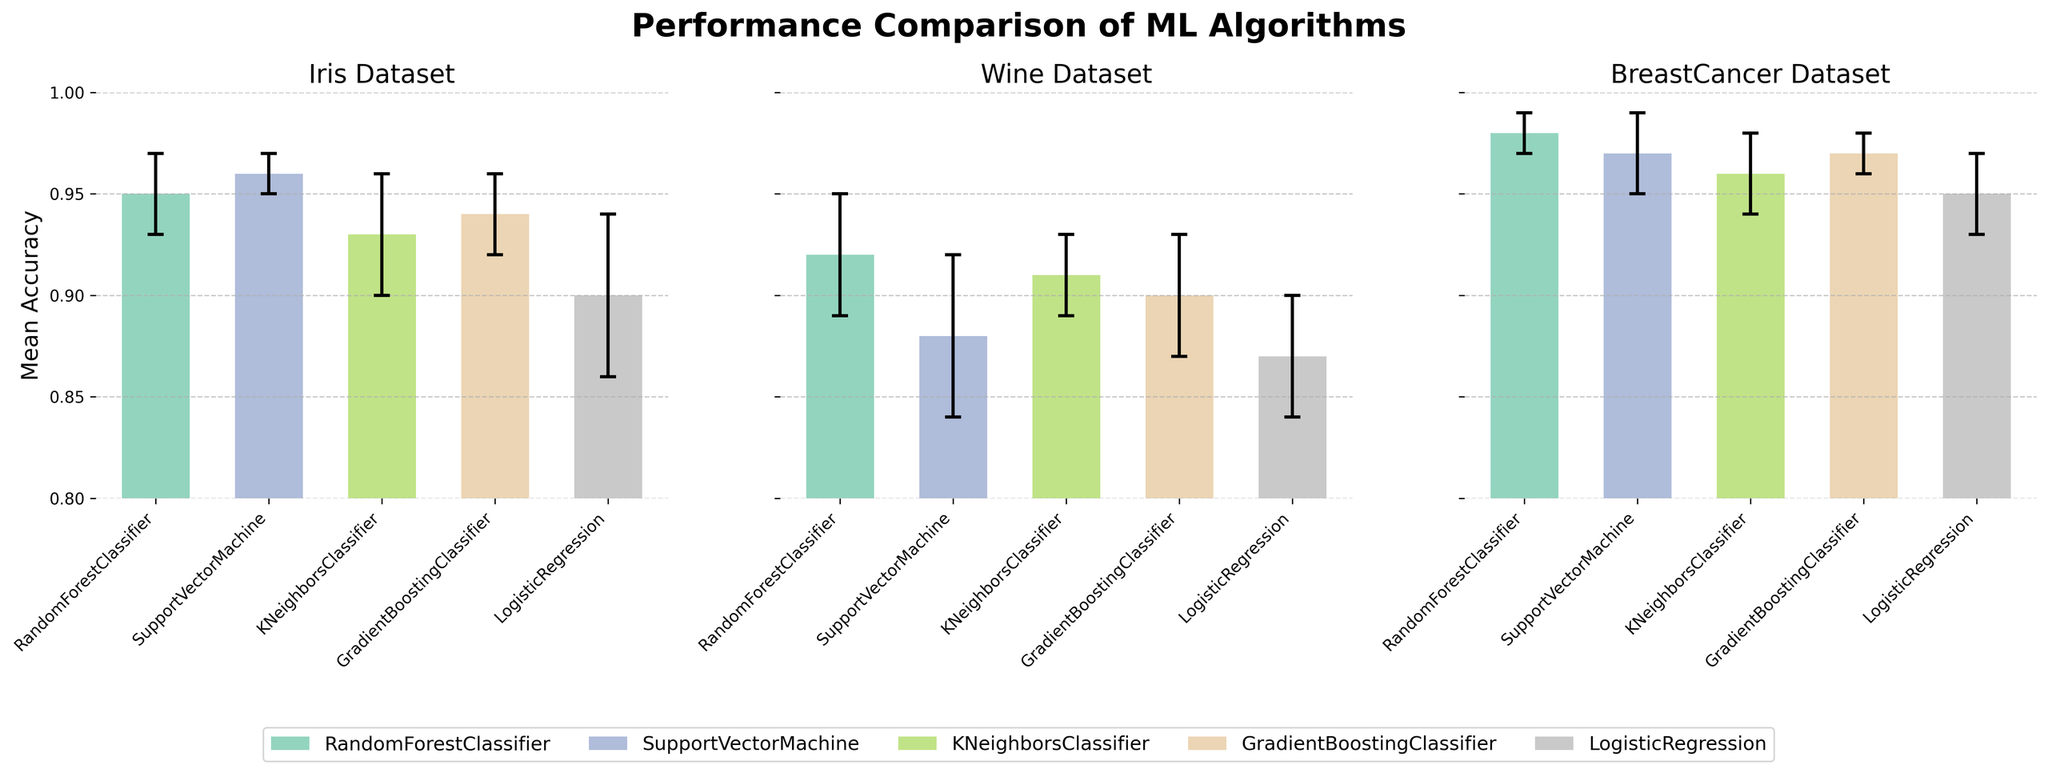Which algorithm has the highest mean accuracy on the Iris dataset? From the Iris dataset subplot, the SupportVectorMachine bar has the highest top compared to other algorithms in terms of mean accuracy.
Answer: SupportVectorMachine Which algorithm has the lowest mean accuracy on the Wine dataset? From the Wine dataset subplot, the LogisticRegression bar is the lowest in terms of mean accuracy.
Answer: LogisticRegression What is the approximate mean accuracy of the RandomForestClassifier on the BreastCancer dataset? In the BreastCancer dataset subplot, the bar for RandomForestClassifier is just below 1.0 on the Mean Accuracy axis.
Answer: 0.98 Compare the mean accuracies of SupportVectorMachine and KNeighborsClassifier on the Wine dataset. Which one is higher? In the Wine dataset subplot, the bar for SupportVectorMachine has a lower mean accuracy than the KNeighborsClassifier.
Answer: KNeighborsClassifier For the Iris dataset, which algorithm has the largest standard deviation in mean accuracy? In the Iris dataset subplot, the LogisticRegression has the longest error bar, indicating the largest standard deviation.
Answer: LogisticRegression Which dataset shows the highest overall mean accuracy across all algorithms? To find the highest overall mean accuracy, compare the tallest bars across subplots. The BreastCancer dataset has bars closer to 1.0 for most algorithms.
Answer: BreastCancer By how much does the mean accuracy of GradientBoostingClassifier on the Wine dataset differ from that on the BreastCancer dataset? The Wine dataset subplot shows mean accuracy of GradientBoostingClassifier around 0.90, and the BreastCancer dataset subplot shows it around 0.97. The difference is 0.97 - 0.90.
Answer: 0.07 How does the mean accuracy of KNeighborsClassifier on the Iris dataset compare to LogisticRegression on the same dataset? In the Iris dataset subplot, the bar for KNeighborsClassifier is higher than the bar for LogisticRegression.
Answer: KNeighborsClassifier is higher What is the range of mean accuracies for the SupportVectorMachine across all datasets? The highest mean accuracy of SupportVectorMachine is on the Iris dataset (0.96), and the lowest is on the Wine dataset (0.88). The range is 0.96 - 0.88.
Answer: 0.08 Which algorithm has consistent performance (small standard deviations) across all datasets? By comparing error bars across all subplots, RandomForestClassifier has the smallest spread in its error bars on all datasets, indicating consistency.
Answer: RandomForestClassifier 